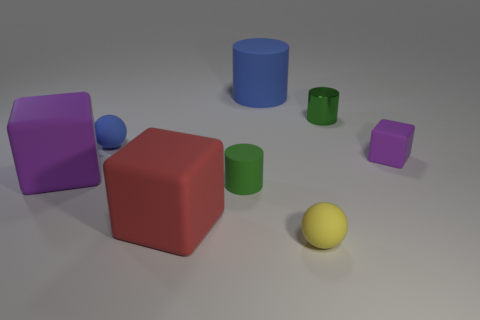Subtract all green cylinders. How many cylinders are left? 1 Subtract 1 cubes. How many cubes are left? 2 Add 2 tiny rubber cubes. How many objects exist? 10 Subtract all cubes. How many objects are left? 5 Add 4 tiny green matte cylinders. How many tiny green matte cylinders exist? 5 Subtract 0 gray cylinders. How many objects are left? 8 Subtract all matte spheres. Subtract all green rubber things. How many objects are left? 5 Add 7 red rubber blocks. How many red rubber blocks are left? 8 